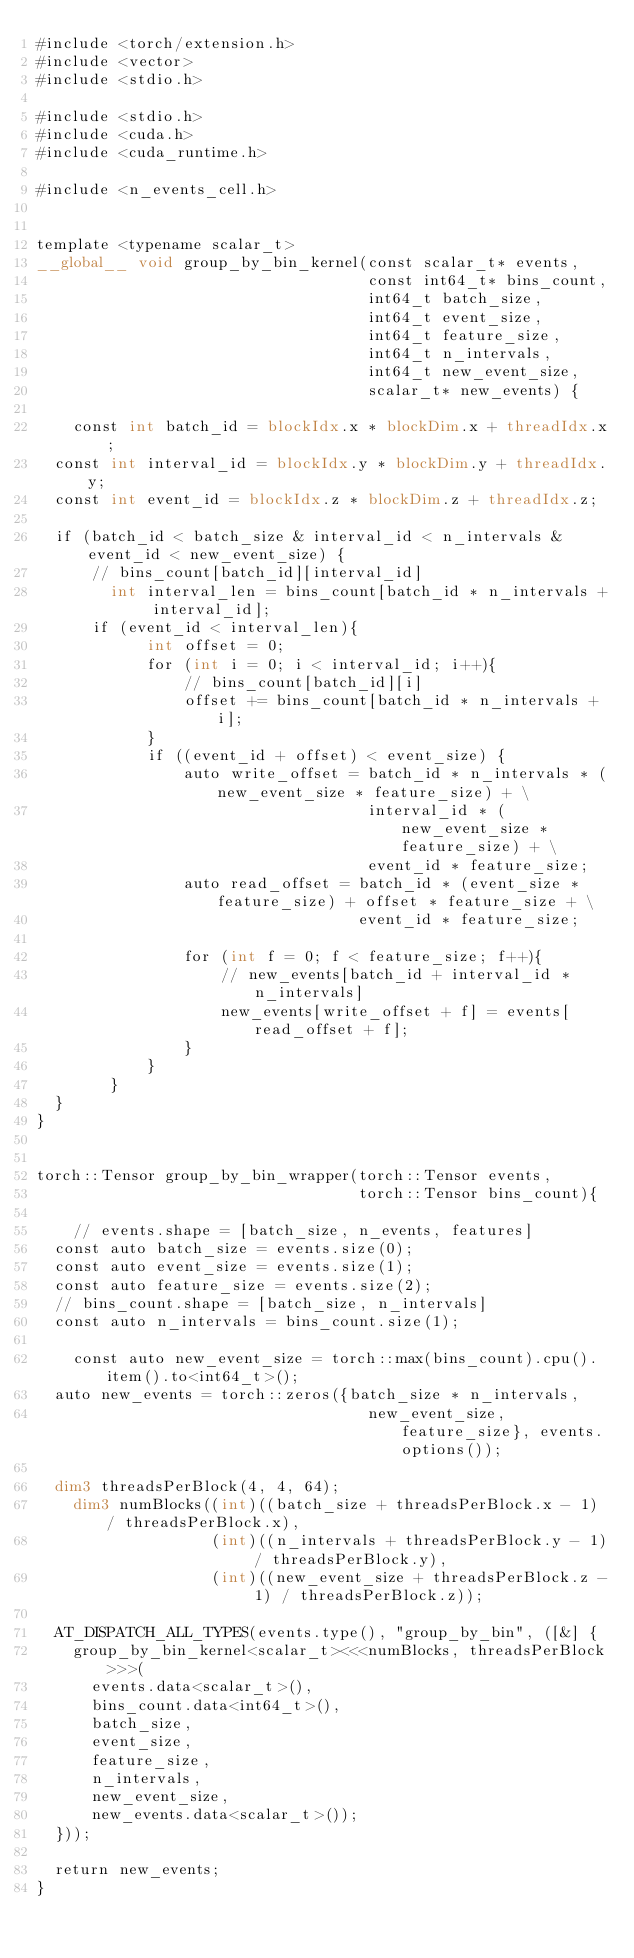<code> <loc_0><loc_0><loc_500><loc_500><_Cuda_>#include <torch/extension.h>
#include <vector>
#include <stdio.h>

#include <stdio.h>
#include <cuda.h>
#include <cuda_runtime.h>

#include <n_events_cell.h>


template <typename scalar_t>
__global__ void group_by_bin_kernel(const scalar_t* events, 
                                    const int64_t* bins_count,
                                    int64_t batch_size, 
                                    int64_t event_size, 
                                    int64_t feature_size,
                                    int64_t n_intervals, 
                                    int64_t new_event_size,
                                    scalar_t* new_events) {

    const int batch_id = blockIdx.x * blockDim.x + threadIdx.x;
	const int interval_id = blockIdx.y * blockDim.y + threadIdx.y;
	const int event_id = blockIdx.z * blockDim.z + threadIdx.z;

	if (batch_id < batch_size & interval_id < n_intervals & event_id < new_event_size) {
	    // bins_count[batch_id][interval_id]
        int interval_len = bins_count[batch_id * n_intervals + interval_id];
	    if (event_id < interval_len){
            int offset = 0;
            for (int i = 0; i < interval_id; i++){
                // bins_count[batch_id][i]
                offset += bins_count[batch_id * n_intervals + i];
            }
            if ((event_id + offset) < event_size) {
                auto write_offset = batch_id * n_intervals * (new_event_size * feature_size) + \
                                    interval_id * (new_event_size * feature_size) + \
                                    event_id * feature_size;
                auto read_offset = batch_id * (event_size * feature_size) + offset * feature_size + \
                                   event_id * feature_size;

                for (int f = 0; f < feature_size; f++){
                    // new_events[batch_id + interval_id * n_intervals]
                    new_events[write_offset + f] = events[read_offset + f];
                }
            }
        }
	}
}


torch::Tensor group_by_bin_wrapper(torch::Tensor events,
                                   torch::Tensor bins_count){

    // events.shape = [batch_size, n_events, features]
	const auto batch_size = events.size(0);
	const auto event_size = events.size(1);
	const auto feature_size = events.size(2);
	// bins_count.shape = [batch_size, n_intervals]
	const auto n_intervals = bins_count.size(1);

    const auto new_event_size = torch::max(bins_count).cpu().item().to<int64_t>();
	auto new_events = torch::zeros({batch_size * n_intervals,
                                    new_event_size, feature_size}, events.options());

	dim3 threadsPerBlock(4, 4, 64);
    dim3 numBlocks((int)((batch_size + threadsPerBlock.x - 1) / threadsPerBlock.x),
                   (int)((n_intervals + threadsPerBlock.y - 1) / threadsPerBlock.y),
                   (int)((new_event_size + threadsPerBlock.z - 1) / threadsPerBlock.z));

	AT_DISPATCH_ALL_TYPES(events.type(), "group_by_bin", ([&] {
		group_by_bin_kernel<scalar_t><<<numBlocks, threadsPerBlock>>>(
			events.data<scalar_t>(),
			bins_count.data<int64_t>(),
			batch_size,
			event_size,
			feature_size,
			n_intervals,
			new_event_size,
			new_events.data<scalar_t>());
	}));

	return new_events;
}
</code> 